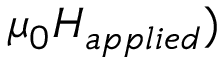<formula> <loc_0><loc_0><loc_500><loc_500>\mu _ { 0 } H _ { a p p l i e d } )</formula> 